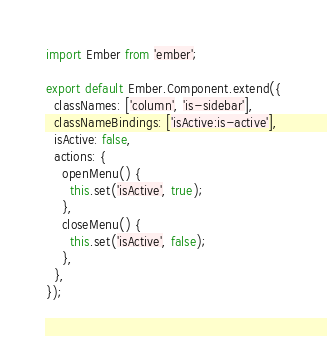<code> <loc_0><loc_0><loc_500><loc_500><_JavaScript_>import Ember from 'ember';

export default Ember.Component.extend({
  classNames: ['column', 'is-sidebar'],
  classNameBindings: ['isActive:is-active'],
  isActive: false,
  actions: {
    openMenu() {
      this.set('isActive', true);
    },
    closeMenu() {
      this.set('isActive', false);
    },
  },
});
</code> 